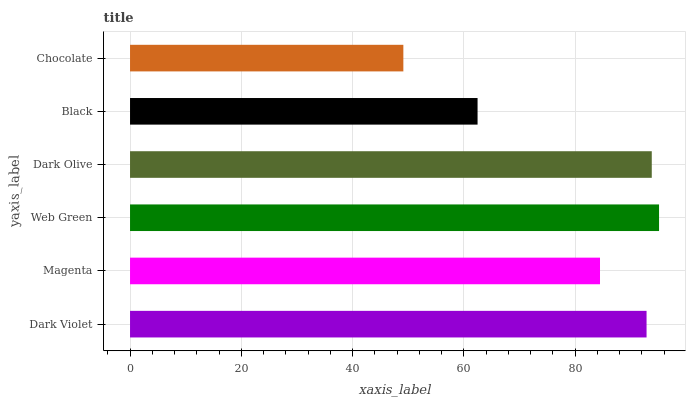Is Chocolate the minimum?
Answer yes or no. Yes. Is Web Green the maximum?
Answer yes or no. Yes. Is Magenta the minimum?
Answer yes or no. No. Is Magenta the maximum?
Answer yes or no. No. Is Dark Violet greater than Magenta?
Answer yes or no. Yes. Is Magenta less than Dark Violet?
Answer yes or no. Yes. Is Magenta greater than Dark Violet?
Answer yes or no. No. Is Dark Violet less than Magenta?
Answer yes or no. No. Is Dark Violet the high median?
Answer yes or no. Yes. Is Magenta the low median?
Answer yes or no. Yes. Is Magenta the high median?
Answer yes or no. No. Is Chocolate the low median?
Answer yes or no. No. 